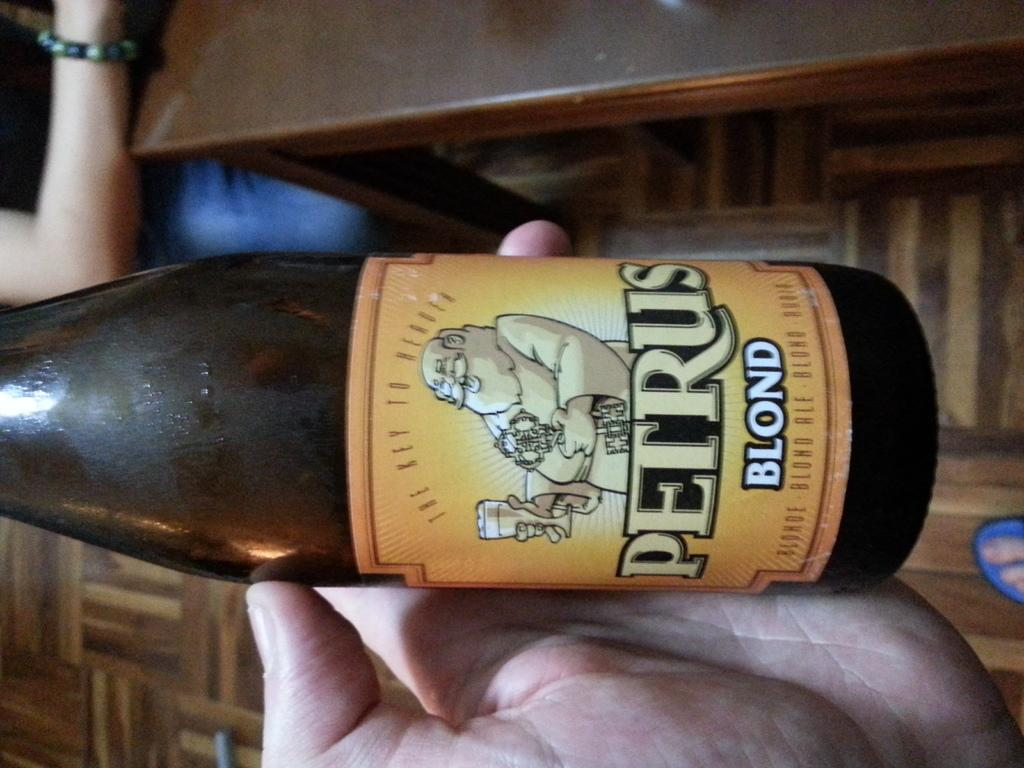What object is being held by a person's hand in the image? There is a bottle in the image that is held by a person's hand. Can you describe the other hand visible in the image? There is another person's hand visible in the background of the image. What type of furniture can be seen in the background of the image? There are cupboards in the background of the image. What color is the shirt worn by the person in the image? There is no information about a shirt or any clothing in the image. 